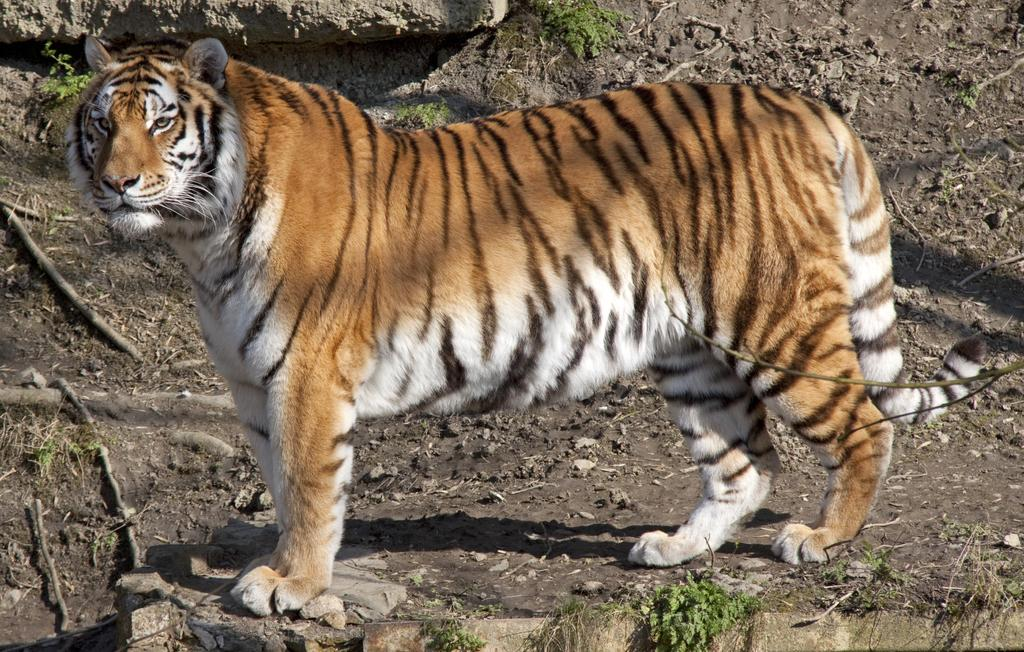What type of animal is in the image? There is a tiger in the image. What natural elements can be seen in the image? Twigs, soil, grass, and a rock are visible in the image. Who is the servant of the tiger in the image? There is no servant present in the image, as it features a tiger in a natural environment. 